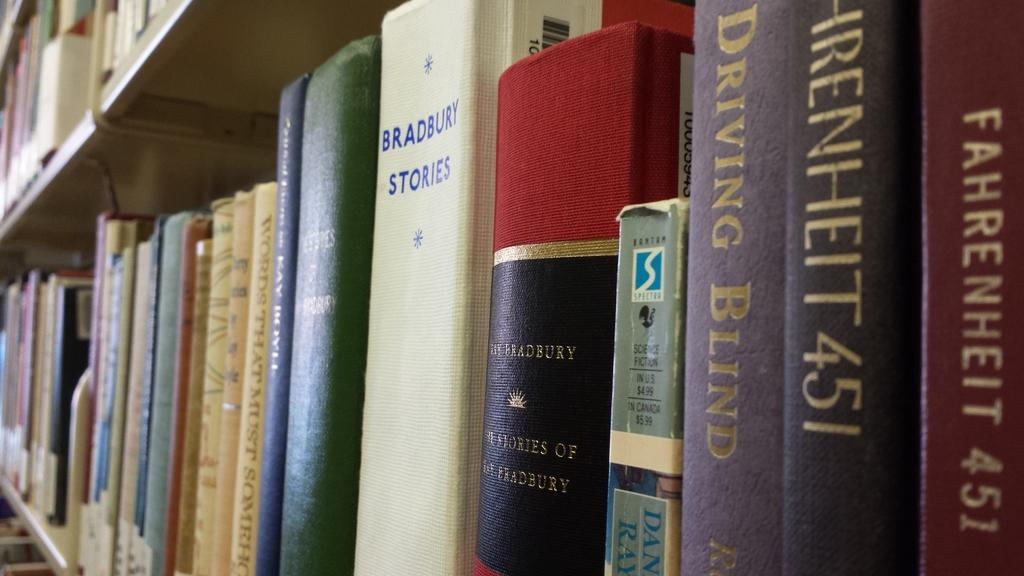<image>
Write a terse but informative summary of the picture. A collection of books including the book Fahrenheit 451. 